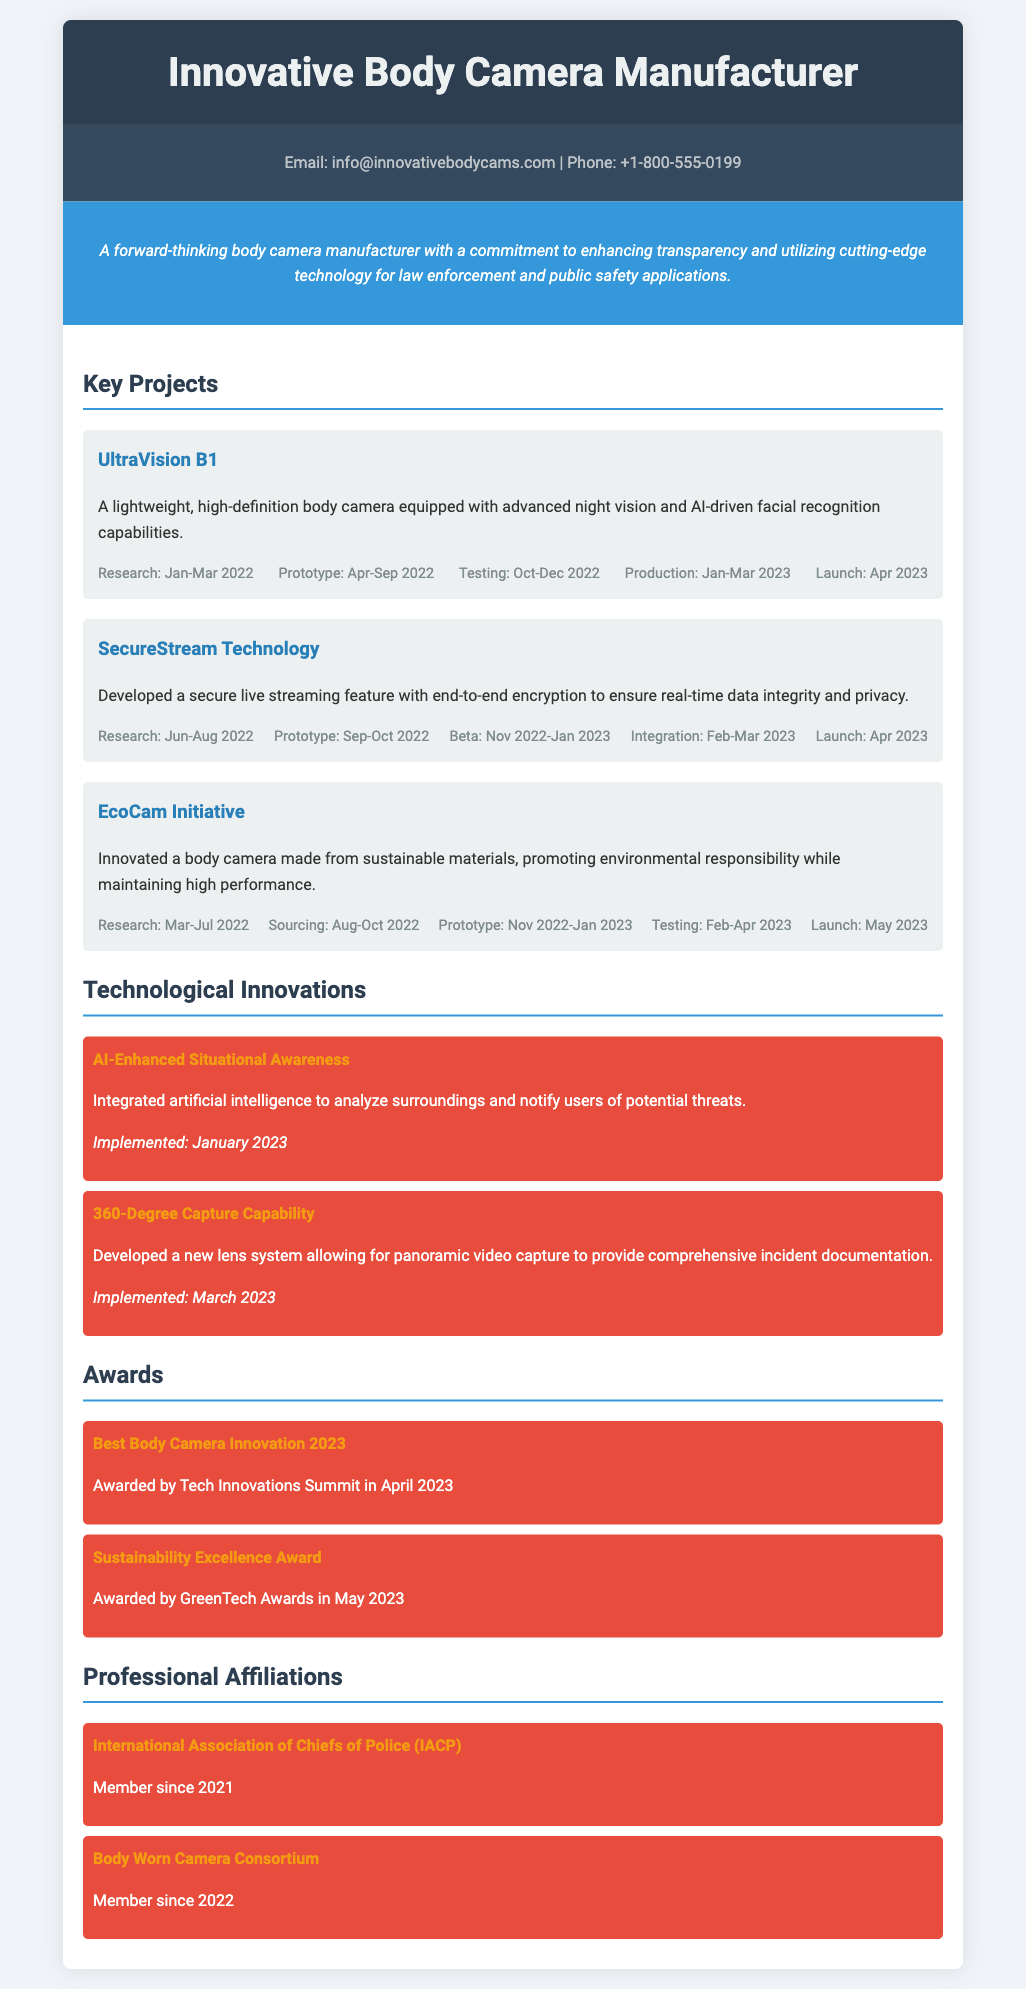What is the name of the first project? The first project listed in the document is "UltraVision B1."
Answer: UltraVision B1 In which month was the SecureStream Technology launched? The document states that the SecureStream Technology was launched in April 2023.
Answer: April 2023 What is the duration of the research phase for the EcoCam Initiative? The EcoCam Initiative research phase spanned from March to July 2022, totaling five months.
Answer: March-Jul 2022 Which innovation was implemented in January 2023? The document specifies that "AI-Enhanced Situational Awareness" was implemented in January 2023.
Answer: AI-Enhanced Situational Awareness How many awards are mentioned in the document? There are two awards mentioned in the awards section of the document.
Answer: Two Which organization has the manufacturer been a member of since 2021? The document indicates membership in the International Association of Chiefs of Police (IACP) since 2021.
Answer: International Association of Chiefs of Police (IACP) What is the main focus of the innovative body camera manufacturer? The focus of the manufacturer, as stated in the document, is on enhancing transparency and utilizing cutting-edge technology.
Answer: Enhancing transparency and utilizing cutting-edge technology What was the launch month for the UltraVision B1? According to the document, the UltraVision B1 was launched in April 2023.
Answer: April 2023 